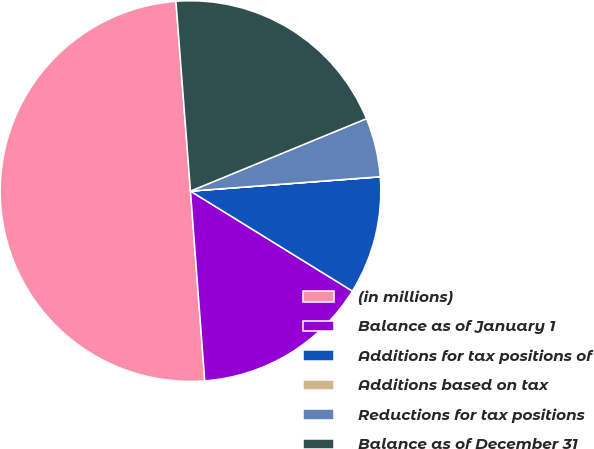Convert chart to OTSL. <chart><loc_0><loc_0><loc_500><loc_500><pie_chart><fcel>(in millions)<fcel>Balance as of January 1<fcel>Additions for tax positions of<fcel>Additions based on tax<fcel>Reductions for tax positions<fcel>Balance as of December 31<nl><fcel>49.98%<fcel>15.0%<fcel>10.0%<fcel>0.01%<fcel>5.01%<fcel>20.0%<nl></chart> 